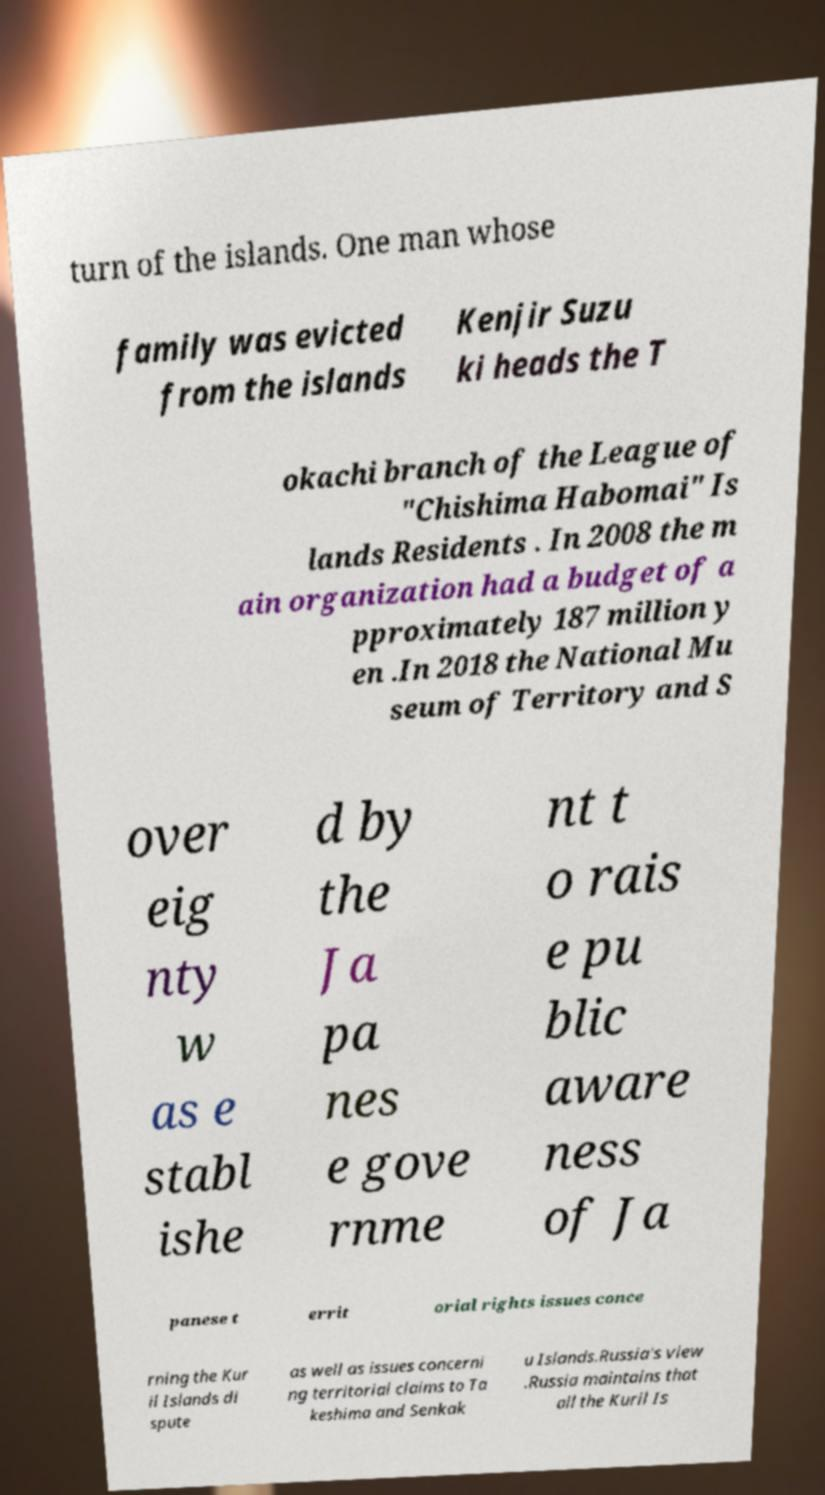Please read and relay the text visible in this image. What does it say? turn of the islands. One man whose family was evicted from the islands Kenjir Suzu ki heads the T okachi branch of the League of "Chishima Habomai" Is lands Residents . In 2008 the m ain organization had a budget of a pproximately 187 million y en .In 2018 the National Mu seum of Territory and S over eig nty w as e stabl ishe d by the Ja pa nes e gove rnme nt t o rais e pu blic aware ness of Ja panese t errit orial rights issues conce rning the Kur il Islands di spute as well as issues concerni ng territorial claims to Ta keshima and Senkak u Islands.Russia's view .Russia maintains that all the Kuril Is 